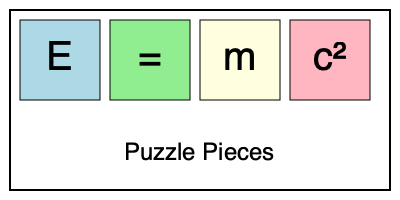Rearrange the puzzle pieces shown above to form Albert Einstein's famous equation. What is the correct order of the pieces to represent the equation $E=mc^2$? To solve this puzzle and form Albert Einstein's famous equation $E=mc^2$, we need to follow these steps:

1. Identify the components of the equation:
   - $E$ represents energy
   - $=$ is the equals sign
   - $m$ represents mass
   - $c^2$ represents the speed of light squared

2. Recognize the correct order of the equation:
   - The equation starts with $E$ (energy)
   - Followed by the equals sign $=$
   - Then $m$ (mass)
   - And finally $c^2$ (speed of light squared)

3. Match the puzzle pieces to the components:
   - The blue piece contains $E$
   - The green piece contains $=$
   - The yellow piece contains $m$
   - The pink piece contains $c^2$

4. Arrange the pieces in the correct order:
   - Blue piece ($E$) should be first
   - Green piece ($=$) should be second
   - Yellow piece ($m$) should be third
   - Pink piece ($c^2$) should be fourth

Therefore, the correct order of the puzzle pieces to represent Einstein's equation $E=mc^2$ is: blue, green, yellow, pink.
Answer: Blue, green, yellow, pink 